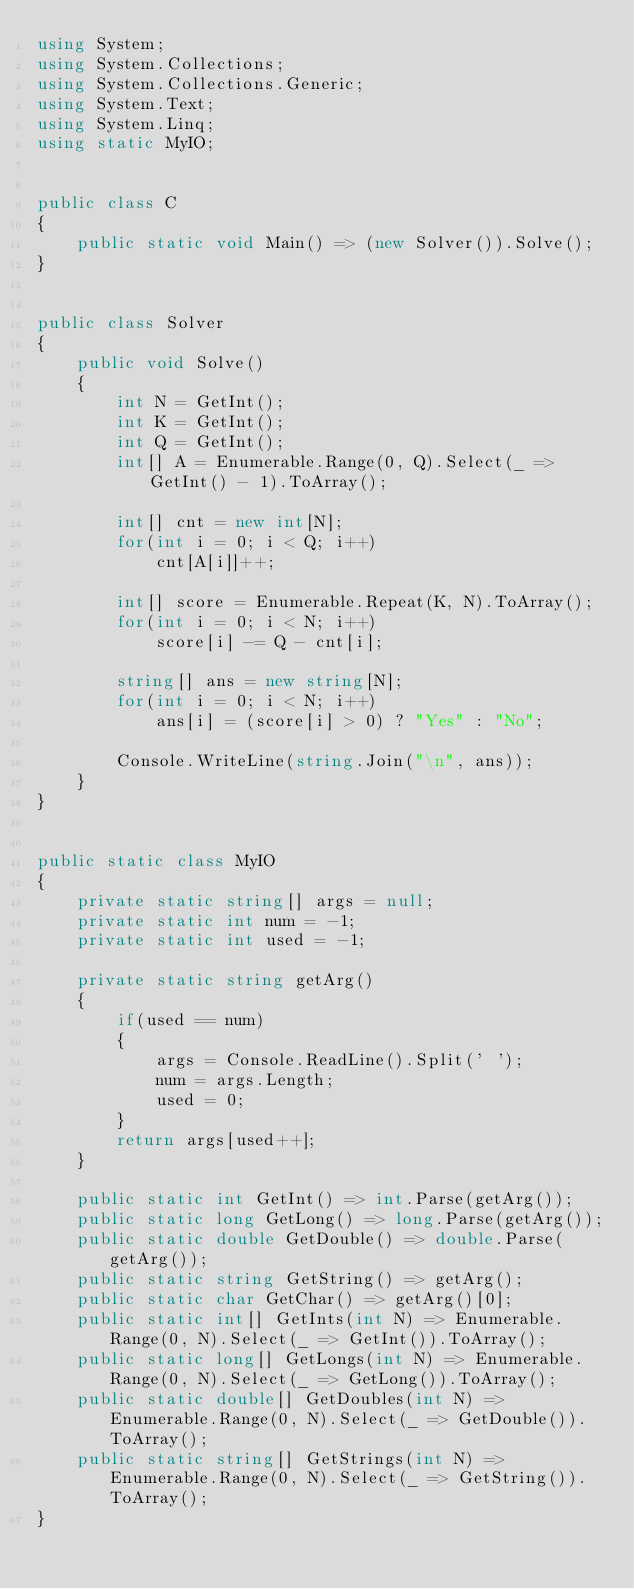Convert code to text. <code><loc_0><loc_0><loc_500><loc_500><_C#_>using System;
using System.Collections;
using System.Collections.Generic;
using System.Text;
using System.Linq;
using static MyIO;


public class C
{
	public static void Main() => (new Solver()).Solve();
}


public class Solver
{
	public void Solve()
	{
		int N = GetInt();
		int K = GetInt();
		int Q = GetInt();
		int[] A = Enumerable.Range(0, Q).Select(_ => GetInt() - 1).ToArray();

		int[] cnt = new int[N];
		for(int i = 0; i < Q; i++)
			cnt[A[i]]++;

		int[] score = Enumerable.Repeat(K, N).ToArray();
		for(int i = 0; i < N; i++)
			score[i] -= Q - cnt[i];

		string[] ans = new string[N];
		for(int i = 0; i < N; i++)
			ans[i] = (score[i] > 0) ? "Yes" : "No";

		Console.WriteLine(string.Join("\n", ans));
	}
}


public static class MyIO
{
	private static string[] args = null;
	private static int num = -1;
	private static int used = -1;

	private static string getArg()
	{
		if(used == num)
		{
			args = Console.ReadLine().Split(' ');
			num = args.Length;
			used = 0;
		}
		return args[used++];
	}

	public static int GetInt() => int.Parse(getArg());
	public static long GetLong() => long.Parse(getArg());
	public static double GetDouble() => double.Parse(getArg());
	public static string GetString() => getArg();
	public static char GetChar() => getArg()[0];
	public static int[] GetInts(int N) => Enumerable.Range(0, N).Select(_ => GetInt()).ToArray();
	public static long[] GetLongs(int N) => Enumerable.Range(0, N).Select(_ => GetLong()).ToArray();
	public static double[] GetDoubles(int N) => Enumerable.Range(0, N).Select(_ => GetDouble()).ToArray();
	public static string[] GetStrings(int N) => Enumerable.Range(0, N).Select(_ => GetString()).ToArray();
}
</code> 